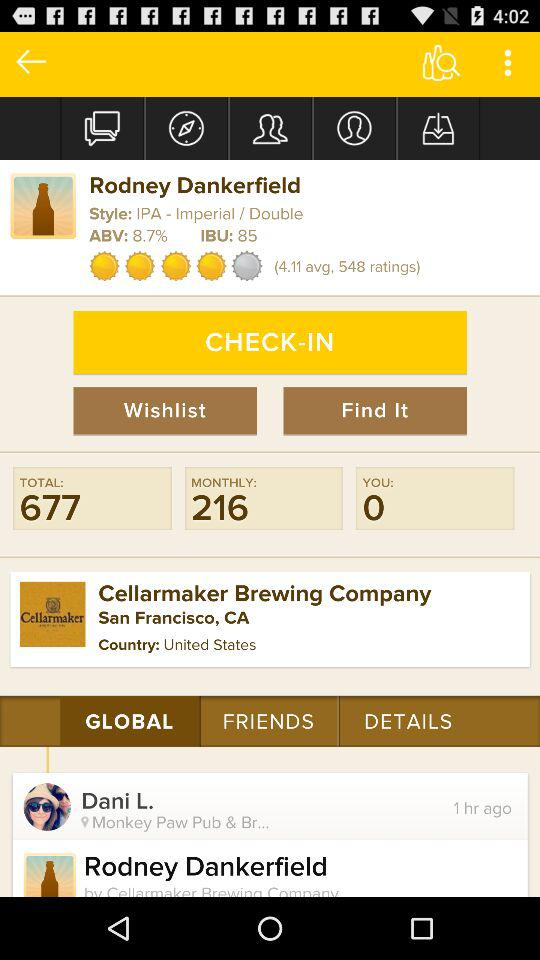Which tab is currently selected? The tab "GLOBAL" is currently selected. 